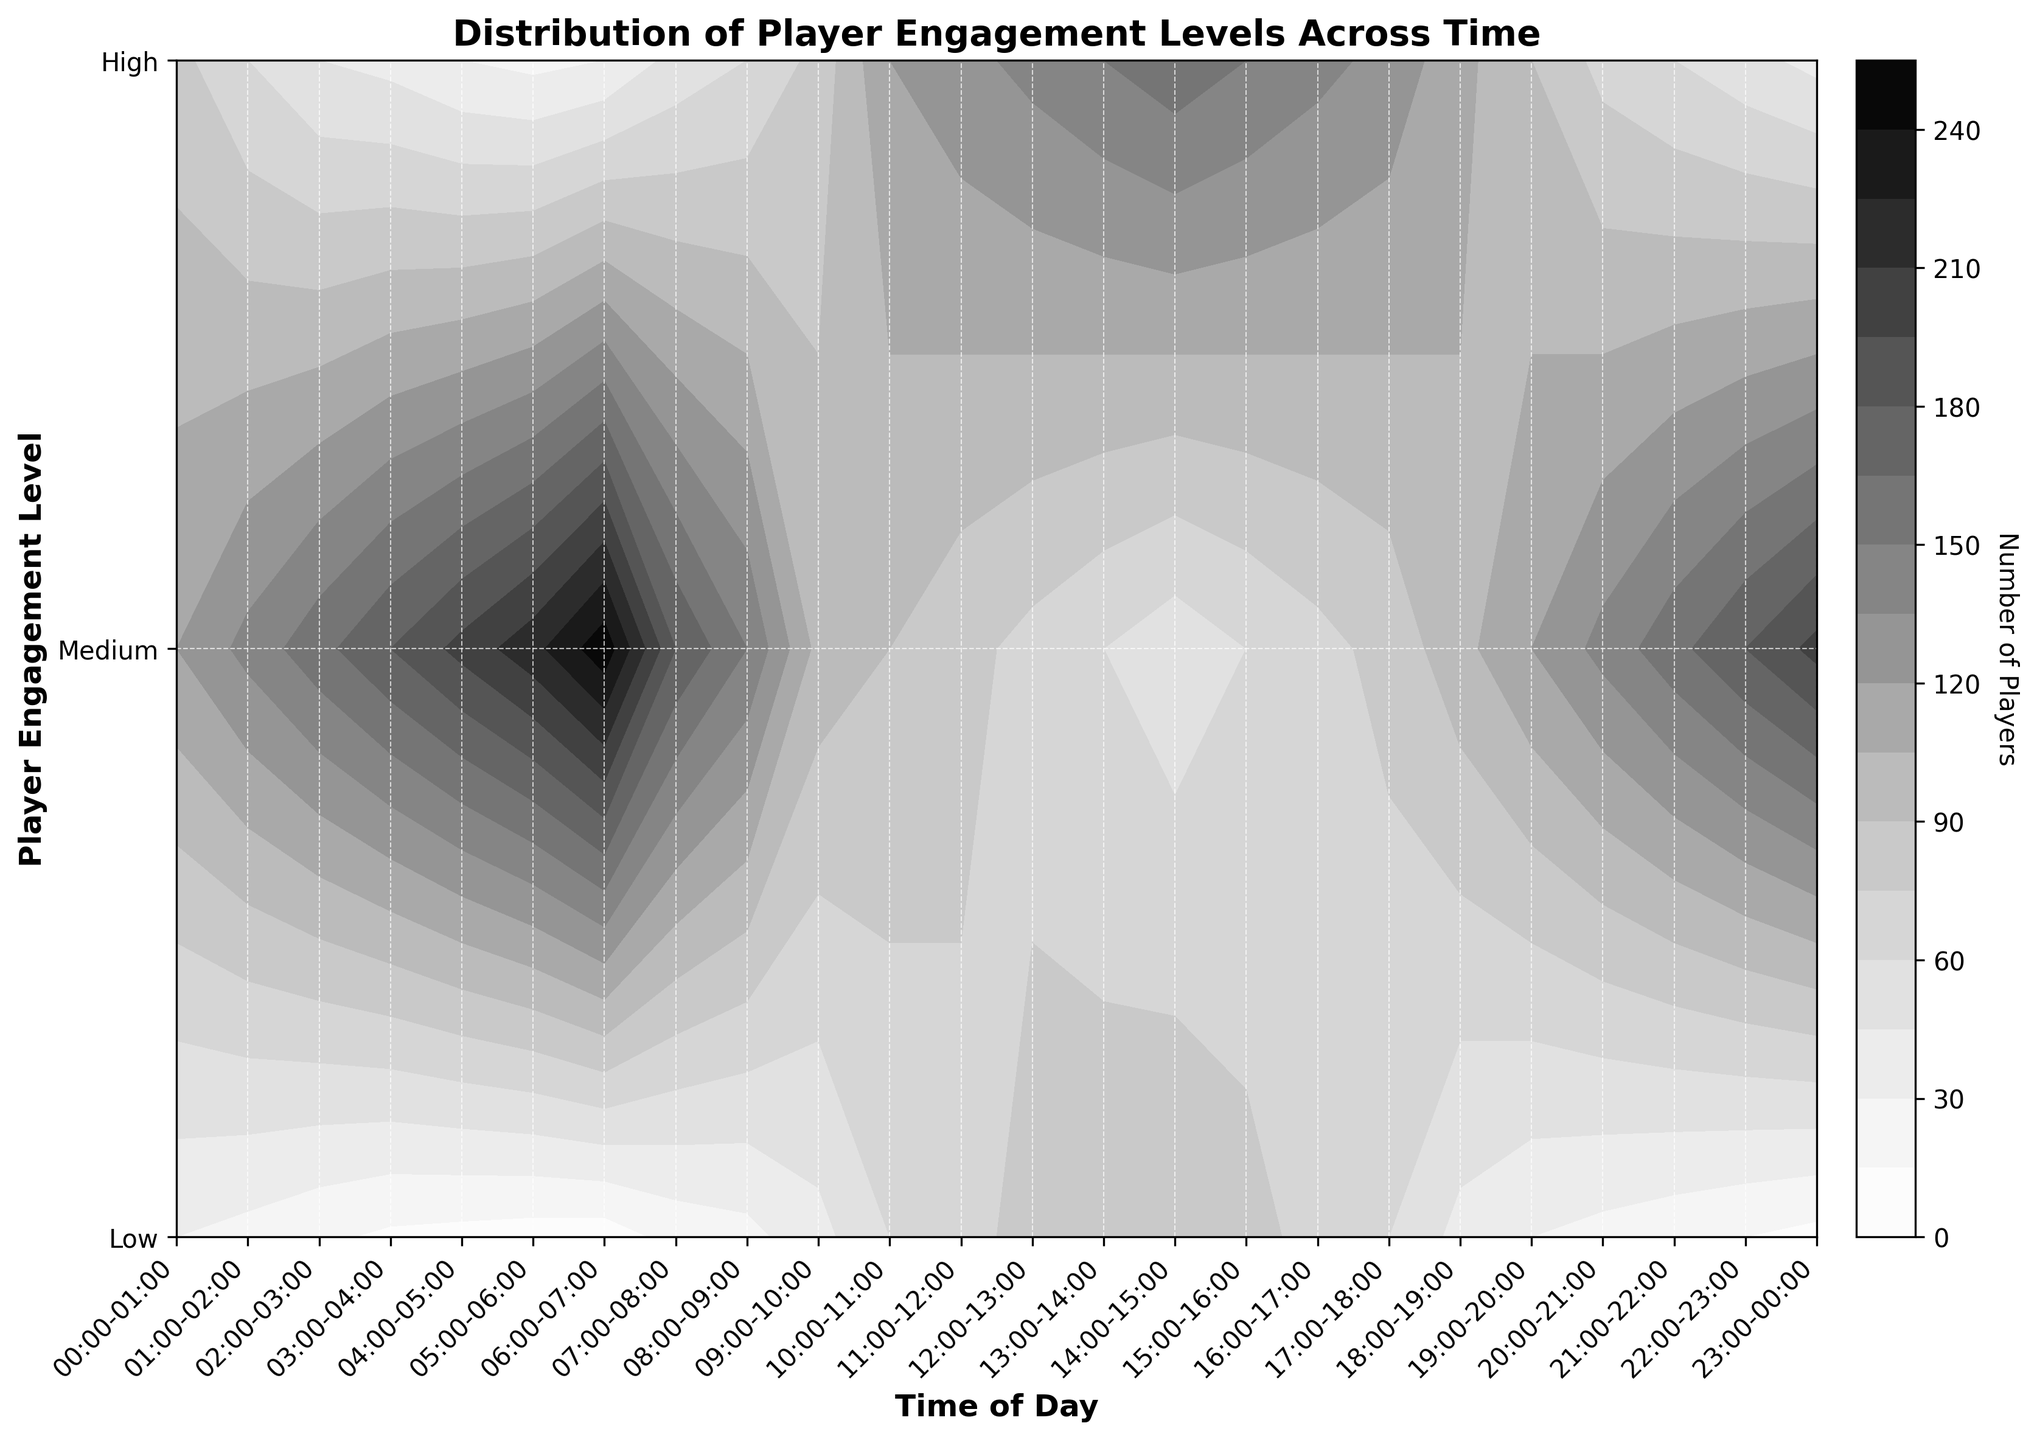What is the title of the figure? The title of the figure is typically placed at the top of the plot. In this case, it clearly states the overall subject of the plot, which is "Distribution of Player Engagement Levels Across Time".
Answer: Distribution of Player Engagement Levels Across Time What does the colorbar represent in the figure? The colorbar indicates the range of values represented by different shades of grey in the contour plot. It specifies the number of players corresponding to each shade. The label on the colorbar confirms this.
Answer: Number of Players At what time do we see the highest engagement levels (High)? To find this, look for the darkest shade of grey along the High row which represents the highest number of players. The darkest area in the High row is around 13:00-14:00.
Answer: 13:00-14:00 Which time period has the lowest number of players with Low engagement? To determine the time with the least players at Low engagement, find the lightest shade of grey in the Low row. The lightest area is around 13:00-14:00.
Answer: 13:00-14:00 Compare the number of Medium engaged players at 09:00-10:00 with that at 12:00-13:00. Which is higher? Observe the shades of grey in the Medium row for the time slots 09:00-10:00 and 12:00-13:00. The area representing 09:00-10:00 is slightly lighter than during 12:00-13:00, indicating fewer players. Therefore, 12:00-13:00 has a higher number of Medium engaged players.
Answer: 12:00-13:00 Around what time do we see a general decrease in both Medium and High engagement levels? Scan the plot from left to right and look at the overall trend for Medium and High rows. Notice a decrease in both Medium and High engagement levels after the 14:00-15:00 time slot.
Answer: After 14:00-15:00 How does the player engagement level distribution compare between early morning (06:00-07:00) and late evening (20:00-21:00)? Examine the shades of grey in the contour plot for the specified times. In the early morning (06:00-07:00), Low engagement is very high (dark grey), Medium is relatively low, and High is minimal. In the late evening (20:00-21:00), Low engagement is still high but less than in the morning, while Medium and High engagement levels are also present but lower than Low. This shows a shift from predominantly Low engagement in the morning to a more balanced but still Low-dominated distribution in the evening.
Answer: More balanced but still Low-dominated in the evening What is the overall trend for the Medium engagement level from 00:00-06:00? Look at the tones in the Medium row from 00:00-06:00. The shades of grey gradually become lighter from left to right, indicating a decrease in the number of Medium engagement players over time.
Answer: Decreasing What trend can be observed in the number of High engagement players from 15:00-19:00? Inspect the High row between 15:00-19:00. The shades of grey become progressively lighter over time, indicating a decrease in the number of High engagement players.
Answer: Decreasing Between which periods does the number of Low engaged players show the most significant increase? Compare the grey shades in the Low row across different periods. The Low engaged players increase steadily but the most significant jump is observed from 03:00-04:00 to 06:00-07:00, where the shades shift to much darker grey significantly.
Answer: 03:00-07:00 